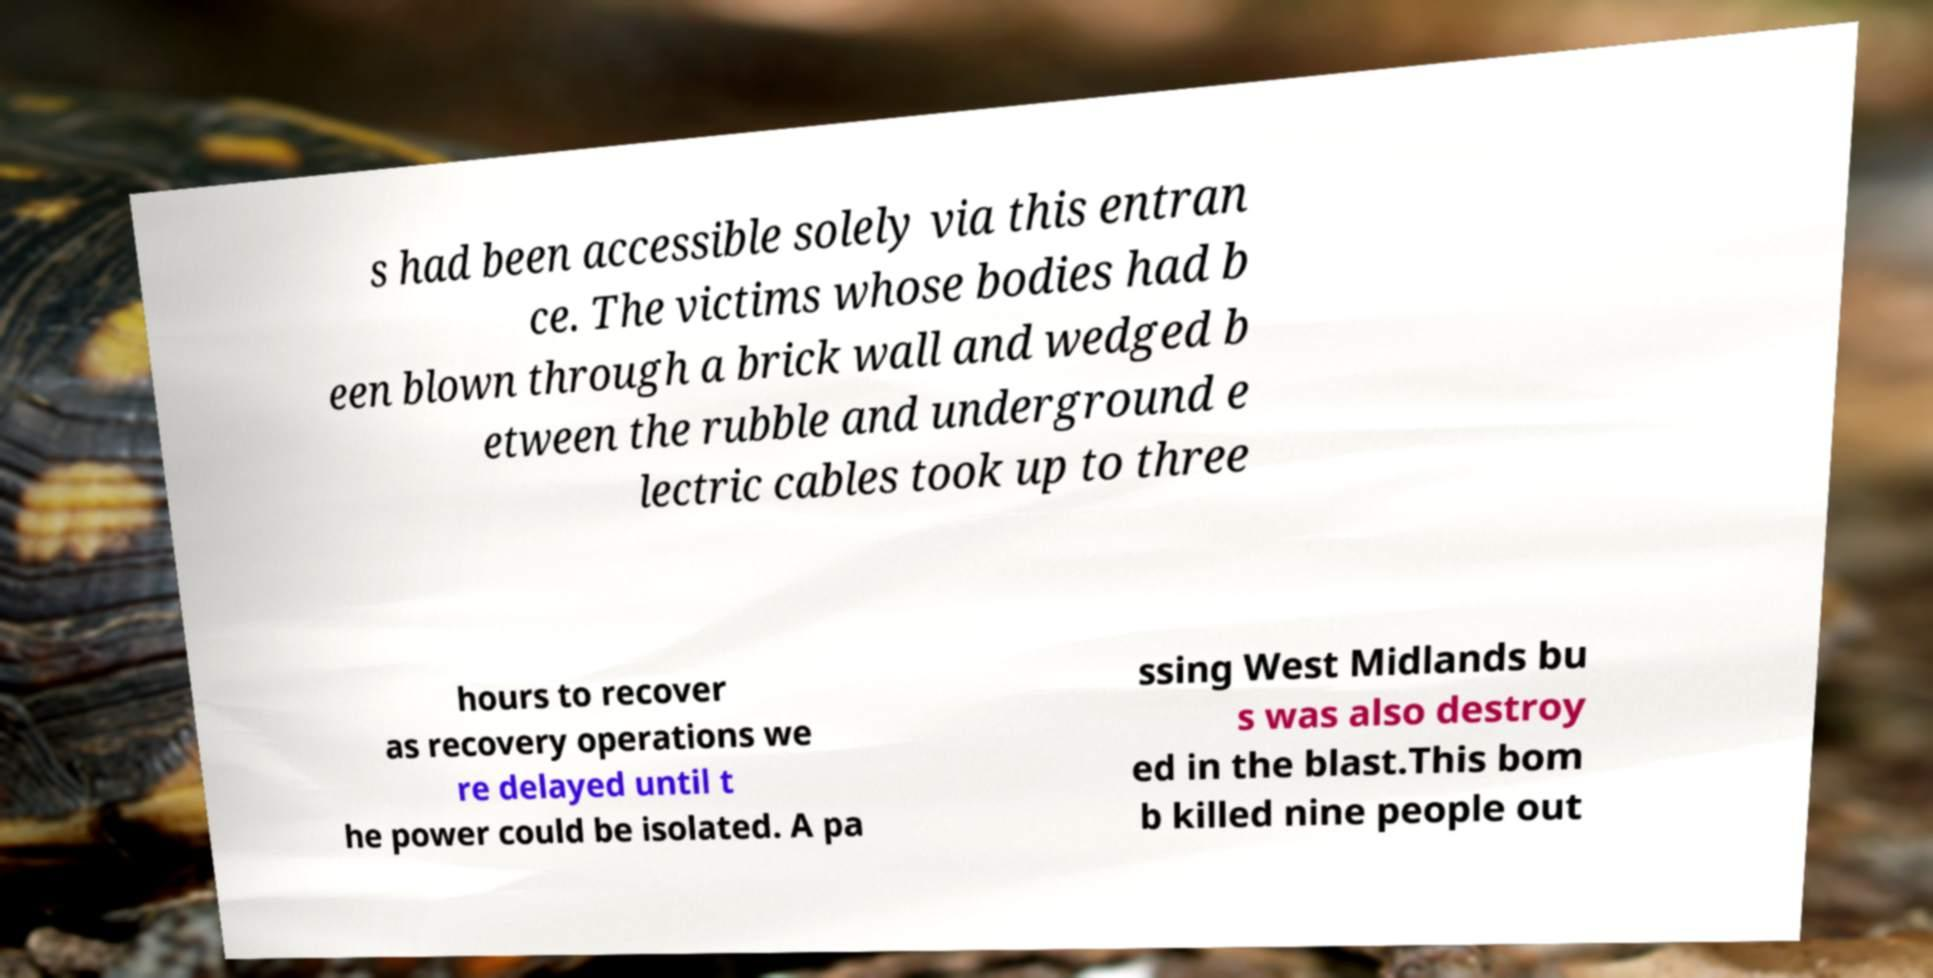Can you read and provide the text displayed in the image?This photo seems to have some interesting text. Can you extract and type it out for me? s had been accessible solely via this entran ce. The victims whose bodies had b een blown through a brick wall and wedged b etween the rubble and underground e lectric cables took up to three hours to recover as recovery operations we re delayed until t he power could be isolated. A pa ssing West Midlands bu s was also destroy ed in the blast.This bom b killed nine people out 